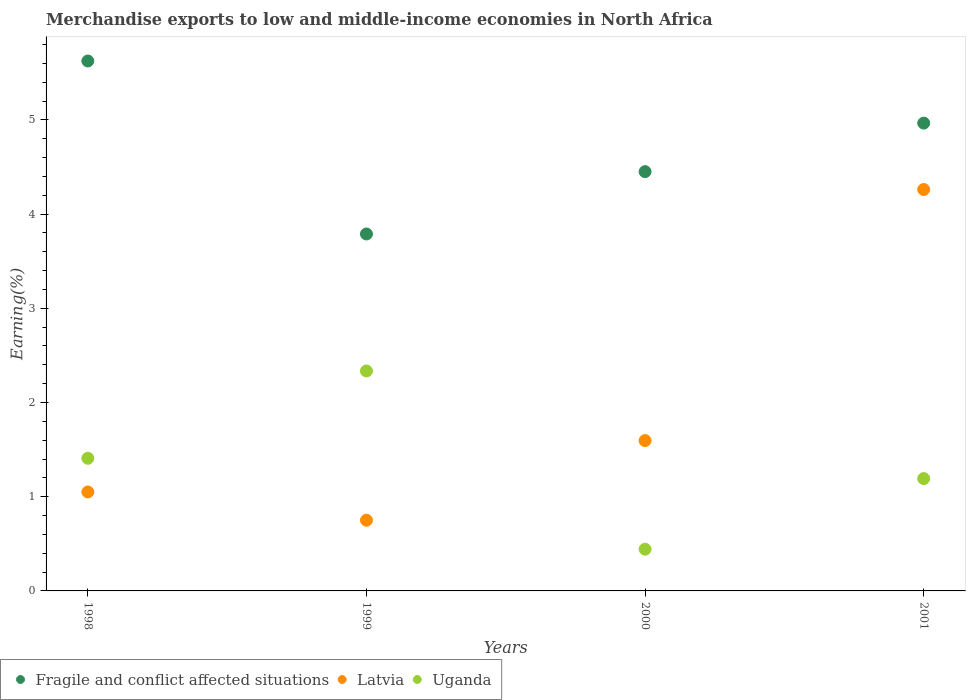What is the percentage of amount earned from merchandise exports in Uganda in 2001?
Offer a very short reply. 1.19. Across all years, what is the maximum percentage of amount earned from merchandise exports in Uganda?
Ensure brevity in your answer.  2.33. Across all years, what is the minimum percentage of amount earned from merchandise exports in Uganda?
Your answer should be compact. 0.44. What is the total percentage of amount earned from merchandise exports in Latvia in the graph?
Offer a very short reply. 7.66. What is the difference between the percentage of amount earned from merchandise exports in Latvia in 1998 and that in 2001?
Your answer should be very brief. -3.21. What is the difference between the percentage of amount earned from merchandise exports in Latvia in 1998 and the percentage of amount earned from merchandise exports in Uganda in 1999?
Ensure brevity in your answer.  -1.28. What is the average percentage of amount earned from merchandise exports in Uganda per year?
Ensure brevity in your answer.  1.34. In the year 2000, what is the difference between the percentage of amount earned from merchandise exports in Uganda and percentage of amount earned from merchandise exports in Fragile and conflict affected situations?
Give a very brief answer. -4.01. What is the ratio of the percentage of amount earned from merchandise exports in Uganda in 1999 to that in 2001?
Make the answer very short. 1.96. What is the difference between the highest and the second highest percentage of amount earned from merchandise exports in Latvia?
Give a very brief answer. 2.67. What is the difference between the highest and the lowest percentage of amount earned from merchandise exports in Latvia?
Provide a succinct answer. 3.51. In how many years, is the percentage of amount earned from merchandise exports in Latvia greater than the average percentage of amount earned from merchandise exports in Latvia taken over all years?
Provide a short and direct response. 1. Is it the case that in every year, the sum of the percentage of amount earned from merchandise exports in Latvia and percentage of amount earned from merchandise exports in Uganda  is greater than the percentage of amount earned from merchandise exports in Fragile and conflict affected situations?
Give a very brief answer. No. Is the percentage of amount earned from merchandise exports in Latvia strictly greater than the percentage of amount earned from merchandise exports in Fragile and conflict affected situations over the years?
Your answer should be compact. No. Does the graph contain any zero values?
Your response must be concise. No. Where does the legend appear in the graph?
Give a very brief answer. Bottom left. How many legend labels are there?
Offer a very short reply. 3. How are the legend labels stacked?
Provide a succinct answer. Horizontal. What is the title of the graph?
Provide a short and direct response. Merchandise exports to low and middle-income economies in North Africa. What is the label or title of the X-axis?
Make the answer very short. Years. What is the label or title of the Y-axis?
Your response must be concise. Earning(%). What is the Earning(%) in Fragile and conflict affected situations in 1998?
Give a very brief answer. 5.63. What is the Earning(%) of Latvia in 1998?
Your answer should be compact. 1.05. What is the Earning(%) in Uganda in 1998?
Give a very brief answer. 1.41. What is the Earning(%) in Fragile and conflict affected situations in 1999?
Give a very brief answer. 3.79. What is the Earning(%) of Latvia in 1999?
Offer a terse response. 0.75. What is the Earning(%) of Uganda in 1999?
Ensure brevity in your answer.  2.33. What is the Earning(%) of Fragile and conflict affected situations in 2000?
Your answer should be compact. 4.45. What is the Earning(%) of Latvia in 2000?
Ensure brevity in your answer.  1.6. What is the Earning(%) of Uganda in 2000?
Your answer should be very brief. 0.44. What is the Earning(%) of Fragile and conflict affected situations in 2001?
Provide a succinct answer. 4.97. What is the Earning(%) of Latvia in 2001?
Give a very brief answer. 4.26. What is the Earning(%) of Uganda in 2001?
Give a very brief answer. 1.19. Across all years, what is the maximum Earning(%) in Fragile and conflict affected situations?
Ensure brevity in your answer.  5.63. Across all years, what is the maximum Earning(%) of Latvia?
Offer a terse response. 4.26. Across all years, what is the maximum Earning(%) in Uganda?
Offer a terse response. 2.33. Across all years, what is the minimum Earning(%) in Fragile and conflict affected situations?
Ensure brevity in your answer.  3.79. Across all years, what is the minimum Earning(%) of Latvia?
Ensure brevity in your answer.  0.75. Across all years, what is the minimum Earning(%) in Uganda?
Give a very brief answer. 0.44. What is the total Earning(%) in Fragile and conflict affected situations in the graph?
Provide a short and direct response. 18.83. What is the total Earning(%) in Latvia in the graph?
Offer a terse response. 7.66. What is the total Earning(%) in Uganda in the graph?
Keep it short and to the point. 5.38. What is the difference between the Earning(%) in Fragile and conflict affected situations in 1998 and that in 1999?
Give a very brief answer. 1.84. What is the difference between the Earning(%) in Latvia in 1998 and that in 1999?
Give a very brief answer. 0.3. What is the difference between the Earning(%) of Uganda in 1998 and that in 1999?
Make the answer very short. -0.93. What is the difference between the Earning(%) of Fragile and conflict affected situations in 1998 and that in 2000?
Give a very brief answer. 1.17. What is the difference between the Earning(%) in Latvia in 1998 and that in 2000?
Give a very brief answer. -0.55. What is the difference between the Earning(%) in Uganda in 1998 and that in 2000?
Offer a terse response. 0.97. What is the difference between the Earning(%) in Fragile and conflict affected situations in 1998 and that in 2001?
Offer a very short reply. 0.66. What is the difference between the Earning(%) of Latvia in 1998 and that in 2001?
Your answer should be very brief. -3.21. What is the difference between the Earning(%) in Uganda in 1998 and that in 2001?
Ensure brevity in your answer.  0.22. What is the difference between the Earning(%) of Fragile and conflict affected situations in 1999 and that in 2000?
Make the answer very short. -0.66. What is the difference between the Earning(%) in Latvia in 1999 and that in 2000?
Offer a very short reply. -0.85. What is the difference between the Earning(%) in Uganda in 1999 and that in 2000?
Your answer should be very brief. 1.89. What is the difference between the Earning(%) of Fragile and conflict affected situations in 1999 and that in 2001?
Your answer should be compact. -1.18. What is the difference between the Earning(%) of Latvia in 1999 and that in 2001?
Make the answer very short. -3.51. What is the difference between the Earning(%) of Uganda in 1999 and that in 2001?
Offer a very short reply. 1.14. What is the difference between the Earning(%) in Fragile and conflict affected situations in 2000 and that in 2001?
Your answer should be compact. -0.52. What is the difference between the Earning(%) in Latvia in 2000 and that in 2001?
Keep it short and to the point. -2.67. What is the difference between the Earning(%) of Uganda in 2000 and that in 2001?
Keep it short and to the point. -0.75. What is the difference between the Earning(%) of Fragile and conflict affected situations in 1998 and the Earning(%) of Latvia in 1999?
Give a very brief answer. 4.87. What is the difference between the Earning(%) of Fragile and conflict affected situations in 1998 and the Earning(%) of Uganda in 1999?
Give a very brief answer. 3.29. What is the difference between the Earning(%) in Latvia in 1998 and the Earning(%) in Uganda in 1999?
Provide a succinct answer. -1.28. What is the difference between the Earning(%) in Fragile and conflict affected situations in 1998 and the Earning(%) in Latvia in 2000?
Give a very brief answer. 4.03. What is the difference between the Earning(%) of Fragile and conflict affected situations in 1998 and the Earning(%) of Uganda in 2000?
Your response must be concise. 5.18. What is the difference between the Earning(%) of Latvia in 1998 and the Earning(%) of Uganda in 2000?
Give a very brief answer. 0.61. What is the difference between the Earning(%) in Fragile and conflict affected situations in 1998 and the Earning(%) in Latvia in 2001?
Offer a very short reply. 1.36. What is the difference between the Earning(%) in Fragile and conflict affected situations in 1998 and the Earning(%) in Uganda in 2001?
Offer a terse response. 4.43. What is the difference between the Earning(%) of Latvia in 1998 and the Earning(%) of Uganda in 2001?
Ensure brevity in your answer.  -0.14. What is the difference between the Earning(%) in Fragile and conflict affected situations in 1999 and the Earning(%) in Latvia in 2000?
Your answer should be compact. 2.19. What is the difference between the Earning(%) of Fragile and conflict affected situations in 1999 and the Earning(%) of Uganda in 2000?
Your answer should be very brief. 3.35. What is the difference between the Earning(%) in Latvia in 1999 and the Earning(%) in Uganda in 2000?
Offer a terse response. 0.31. What is the difference between the Earning(%) in Fragile and conflict affected situations in 1999 and the Earning(%) in Latvia in 2001?
Your answer should be very brief. -0.47. What is the difference between the Earning(%) of Fragile and conflict affected situations in 1999 and the Earning(%) of Uganda in 2001?
Keep it short and to the point. 2.6. What is the difference between the Earning(%) in Latvia in 1999 and the Earning(%) in Uganda in 2001?
Provide a succinct answer. -0.44. What is the difference between the Earning(%) in Fragile and conflict affected situations in 2000 and the Earning(%) in Latvia in 2001?
Ensure brevity in your answer.  0.19. What is the difference between the Earning(%) of Fragile and conflict affected situations in 2000 and the Earning(%) of Uganda in 2001?
Ensure brevity in your answer.  3.26. What is the difference between the Earning(%) in Latvia in 2000 and the Earning(%) in Uganda in 2001?
Make the answer very short. 0.4. What is the average Earning(%) of Fragile and conflict affected situations per year?
Offer a very short reply. 4.71. What is the average Earning(%) in Latvia per year?
Provide a short and direct response. 1.91. What is the average Earning(%) of Uganda per year?
Ensure brevity in your answer.  1.34. In the year 1998, what is the difference between the Earning(%) of Fragile and conflict affected situations and Earning(%) of Latvia?
Provide a succinct answer. 4.57. In the year 1998, what is the difference between the Earning(%) of Fragile and conflict affected situations and Earning(%) of Uganda?
Offer a terse response. 4.22. In the year 1998, what is the difference between the Earning(%) of Latvia and Earning(%) of Uganda?
Your answer should be very brief. -0.36. In the year 1999, what is the difference between the Earning(%) in Fragile and conflict affected situations and Earning(%) in Latvia?
Offer a very short reply. 3.04. In the year 1999, what is the difference between the Earning(%) in Fragile and conflict affected situations and Earning(%) in Uganda?
Your answer should be compact. 1.45. In the year 1999, what is the difference between the Earning(%) in Latvia and Earning(%) in Uganda?
Your answer should be compact. -1.58. In the year 2000, what is the difference between the Earning(%) of Fragile and conflict affected situations and Earning(%) of Latvia?
Provide a succinct answer. 2.85. In the year 2000, what is the difference between the Earning(%) of Fragile and conflict affected situations and Earning(%) of Uganda?
Ensure brevity in your answer.  4.01. In the year 2000, what is the difference between the Earning(%) of Latvia and Earning(%) of Uganda?
Provide a short and direct response. 1.15. In the year 2001, what is the difference between the Earning(%) in Fragile and conflict affected situations and Earning(%) in Latvia?
Your answer should be compact. 0.7. In the year 2001, what is the difference between the Earning(%) in Fragile and conflict affected situations and Earning(%) in Uganda?
Make the answer very short. 3.77. In the year 2001, what is the difference between the Earning(%) of Latvia and Earning(%) of Uganda?
Make the answer very short. 3.07. What is the ratio of the Earning(%) of Fragile and conflict affected situations in 1998 to that in 1999?
Ensure brevity in your answer.  1.48. What is the ratio of the Earning(%) of Latvia in 1998 to that in 1999?
Offer a terse response. 1.4. What is the ratio of the Earning(%) in Uganda in 1998 to that in 1999?
Give a very brief answer. 0.6. What is the ratio of the Earning(%) in Fragile and conflict affected situations in 1998 to that in 2000?
Offer a very short reply. 1.26. What is the ratio of the Earning(%) of Latvia in 1998 to that in 2000?
Your answer should be compact. 0.66. What is the ratio of the Earning(%) in Uganda in 1998 to that in 2000?
Offer a terse response. 3.18. What is the ratio of the Earning(%) of Fragile and conflict affected situations in 1998 to that in 2001?
Provide a succinct answer. 1.13. What is the ratio of the Earning(%) of Latvia in 1998 to that in 2001?
Offer a terse response. 0.25. What is the ratio of the Earning(%) in Uganda in 1998 to that in 2001?
Offer a terse response. 1.18. What is the ratio of the Earning(%) in Fragile and conflict affected situations in 1999 to that in 2000?
Your response must be concise. 0.85. What is the ratio of the Earning(%) of Latvia in 1999 to that in 2000?
Make the answer very short. 0.47. What is the ratio of the Earning(%) of Uganda in 1999 to that in 2000?
Provide a succinct answer. 5.27. What is the ratio of the Earning(%) in Fragile and conflict affected situations in 1999 to that in 2001?
Ensure brevity in your answer.  0.76. What is the ratio of the Earning(%) in Latvia in 1999 to that in 2001?
Your answer should be very brief. 0.18. What is the ratio of the Earning(%) in Uganda in 1999 to that in 2001?
Offer a terse response. 1.96. What is the ratio of the Earning(%) in Fragile and conflict affected situations in 2000 to that in 2001?
Provide a short and direct response. 0.9. What is the ratio of the Earning(%) in Latvia in 2000 to that in 2001?
Make the answer very short. 0.37. What is the ratio of the Earning(%) in Uganda in 2000 to that in 2001?
Provide a succinct answer. 0.37. What is the difference between the highest and the second highest Earning(%) of Fragile and conflict affected situations?
Keep it short and to the point. 0.66. What is the difference between the highest and the second highest Earning(%) in Latvia?
Give a very brief answer. 2.67. What is the difference between the highest and the second highest Earning(%) in Uganda?
Offer a very short reply. 0.93. What is the difference between the highest and the lowest Earning(%) of Fragile and conflict affected situations?
Your answer should be compact. 1.84. What is the difference between the highest and the lowest Earning(%) in Latvia?
Keep it short and to the point. 3.51. What is the difference between the highest and the lowest Earning(%) in Uganda?
Provide a succinct answer. 1.89. 